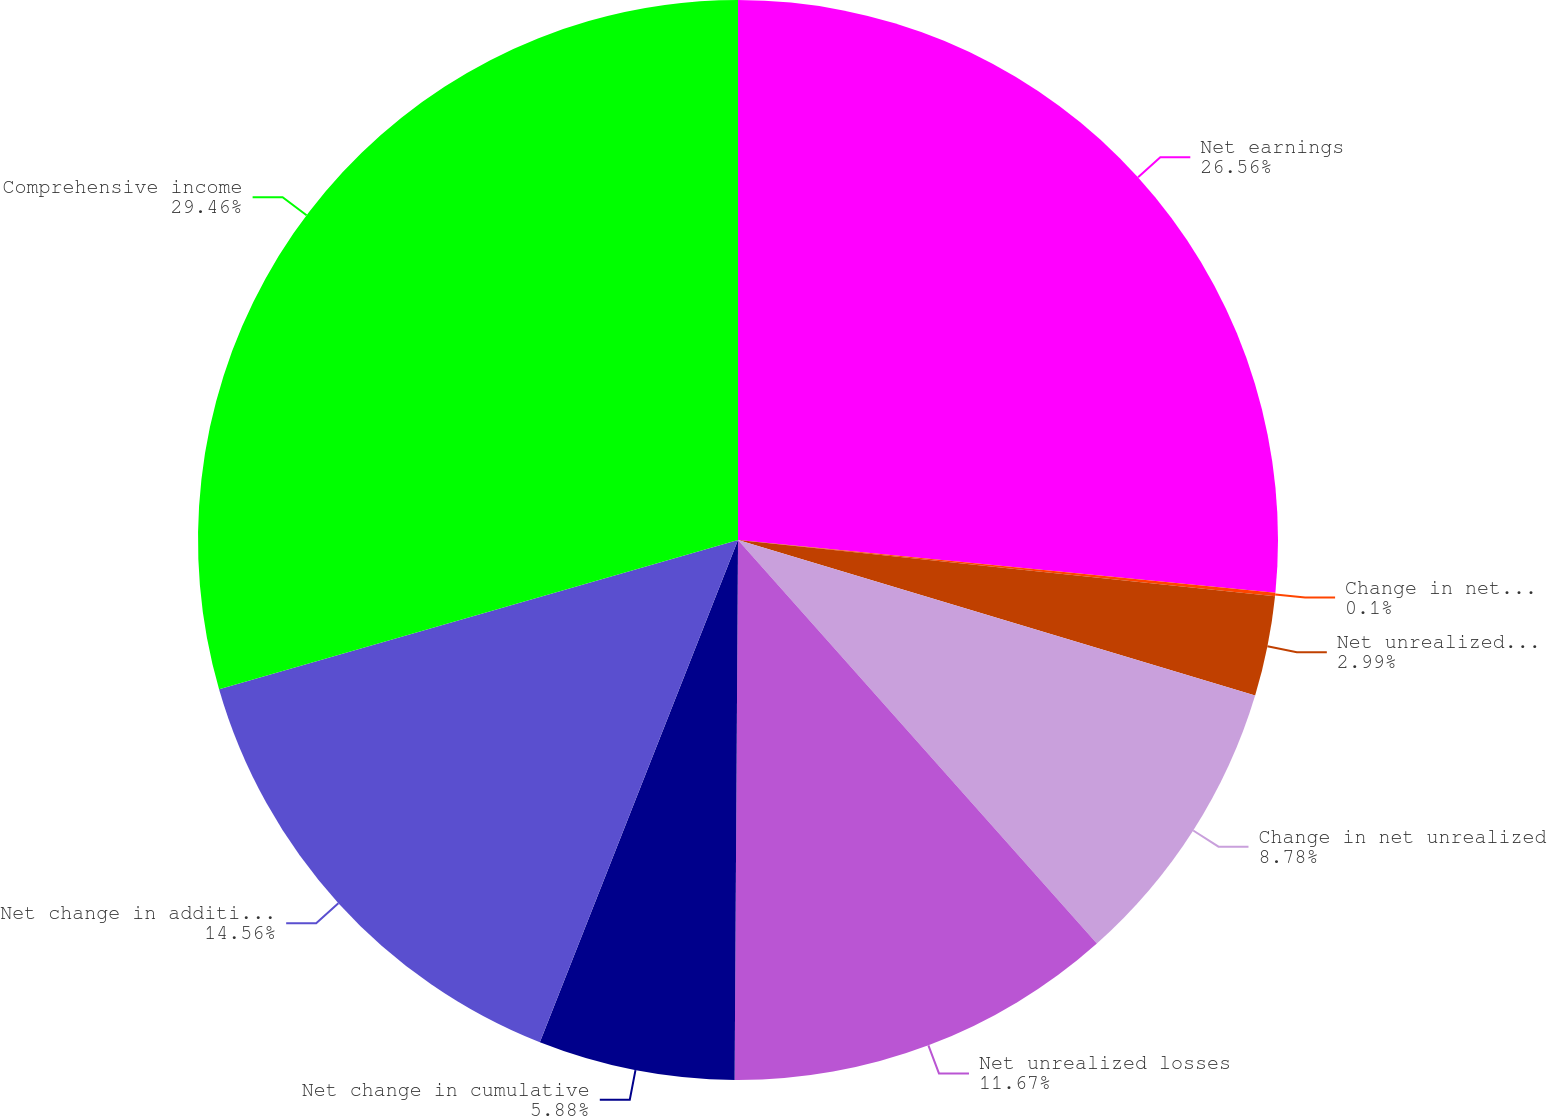Convert chart. <chart><loc_0><loc_0><loc_500><loc_500><pie_chart><fcel>Net earnings<fcel>Change in net unrealized gains<fcel>Net unrealized gains<fcel>Change in net unrealized<fcel>Net unrealized losses<fcel>Net change in cumulative<fcel>Net change in additional<fcel>Comprehensive income<nl><fcel>26.56%<fcel>0.1%<fcel>2.99%<fcel>8.78%<fcel>11.67%<fcel>5.88%<fcel>14.56%<fcel>29.46%<nl></chart> 